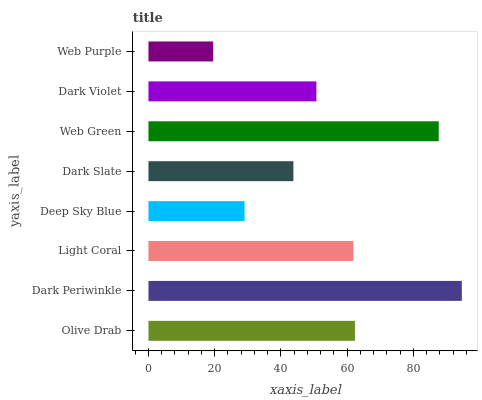Is Web Purple the minimum?
Answer yes or no. Yes. Is Dark Periwinkle the maximum?
Answer yes or no. Yes. Is Light Coral the minimum?
Answer yes or no. No. Is Light Coral the maximum?
Answer yes or no. No. Is Dark Periwinkle greater than Light Coral?
Answer yes or no. Yes. Is Light Coral less than Dark Periwinkle?
Answer yes or no. Yes. Is Light Coral greater than Dark Periwinkle?
Answer yes or no. No. Is Dark Periwinkle less than Light Coral?
Answer yes or no. No. Is Light Coral the high median?
Answer yes or no. Yes. Is Dark Violet the low median?
Answer yes or no. Yes. Is Dark Violet the high median?
Answer yes or no. No. Is Dark Slate the low median?
Answer yes or no. No. 